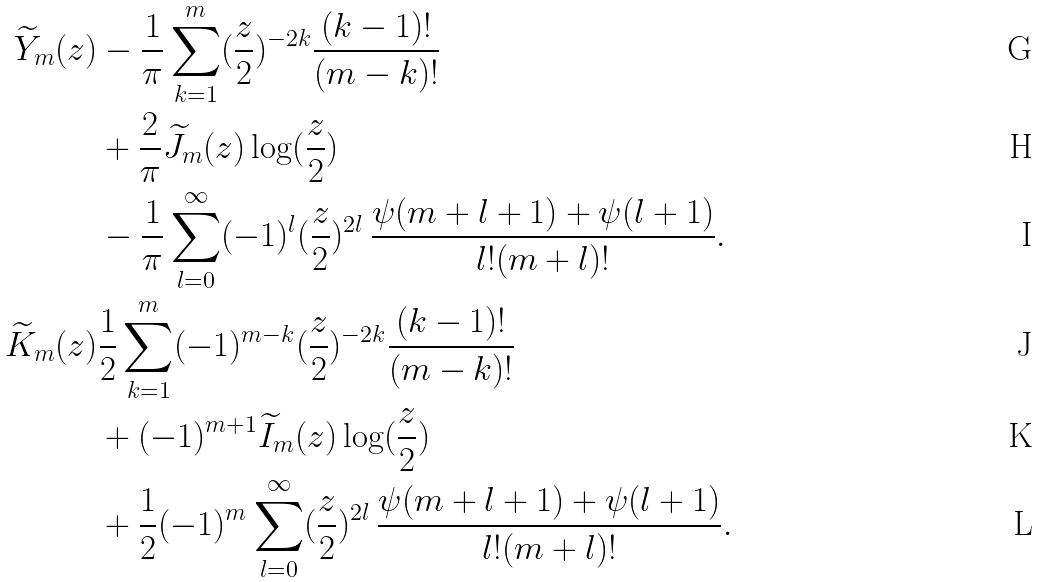<formula> <loc_0><loc_0><loc_500><loc_500>\widetilde { Y } _ { m } ( z ) & - \frac { 1 } { \pi } \sum _ { k = 1 } ^ { m } ( \frac { z } { 2 } ) ^ { - 2 k } \frac { ( k - 1 ) ! } { ( m - k ) ! } \\ & + \frac { 2 } { \pi } \widetilde { J } _ { m } ( z ) \log ( \frac { z } { 2 } ) \\ & - \frac { 1 } { \pi } \sum _ { l = 0 } ^ { \infty } ( - 1 ) ^ { l } ( \frac { z } { 2 } ) ^ { 2 l } \, \frac { \psi ( m + l + 1 ) + \psi ( l + 1 ) } { l ! ( m + l ) ! } . \\ \widetilde { K } _ { m } ( z ) & \frac { 1 } { 2 } \sum _ { k = 1 } ^ { m } ( - 1 ) ^ { m - k } ( \frac { z } { 2 } ) ^ { - 2 k } \frac { ( k - 1 ) ! } { ( m - k ) ! } \\ & + ( - 1 ) ^ { m + 1 } \widetilde { I } _ { m } ( z ) \log ( \frac { z } { 2 } ) \\ & + \frac { 1 } { 2 } ( - 1 ) ^ { m } \sum _ { l = 0 } ^ { \infty } ( \frac { z } { 2 } ) ^ { 2 l } \, \frac { \psi ( m + l + 1 ) + \psi ( l + 1 ) } { l ! ( m + l ) ! } .</formula> 